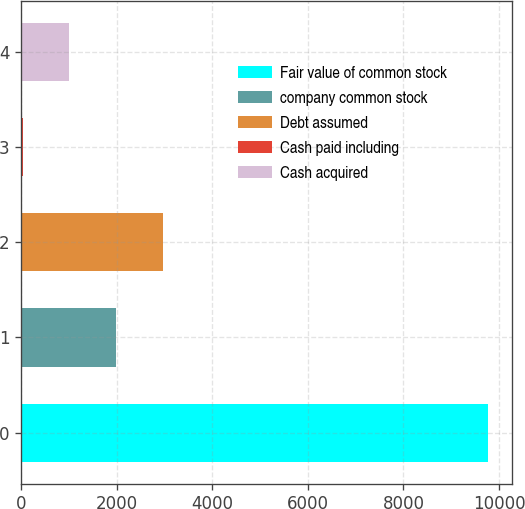Convert chart. <chart><loc_0><loc_0><loc_500><loc_500><bar_chart><fcel>Fair value of common stock<fcel>company common stock<fcel>Debt assumed<fcel>Cash paid including<fcel>Cash acquired<nl><fcel>9777.8<fcel>1985.56<fcel>2959.59<fcel>37.5<fcel>1011.53<nl></chart> 